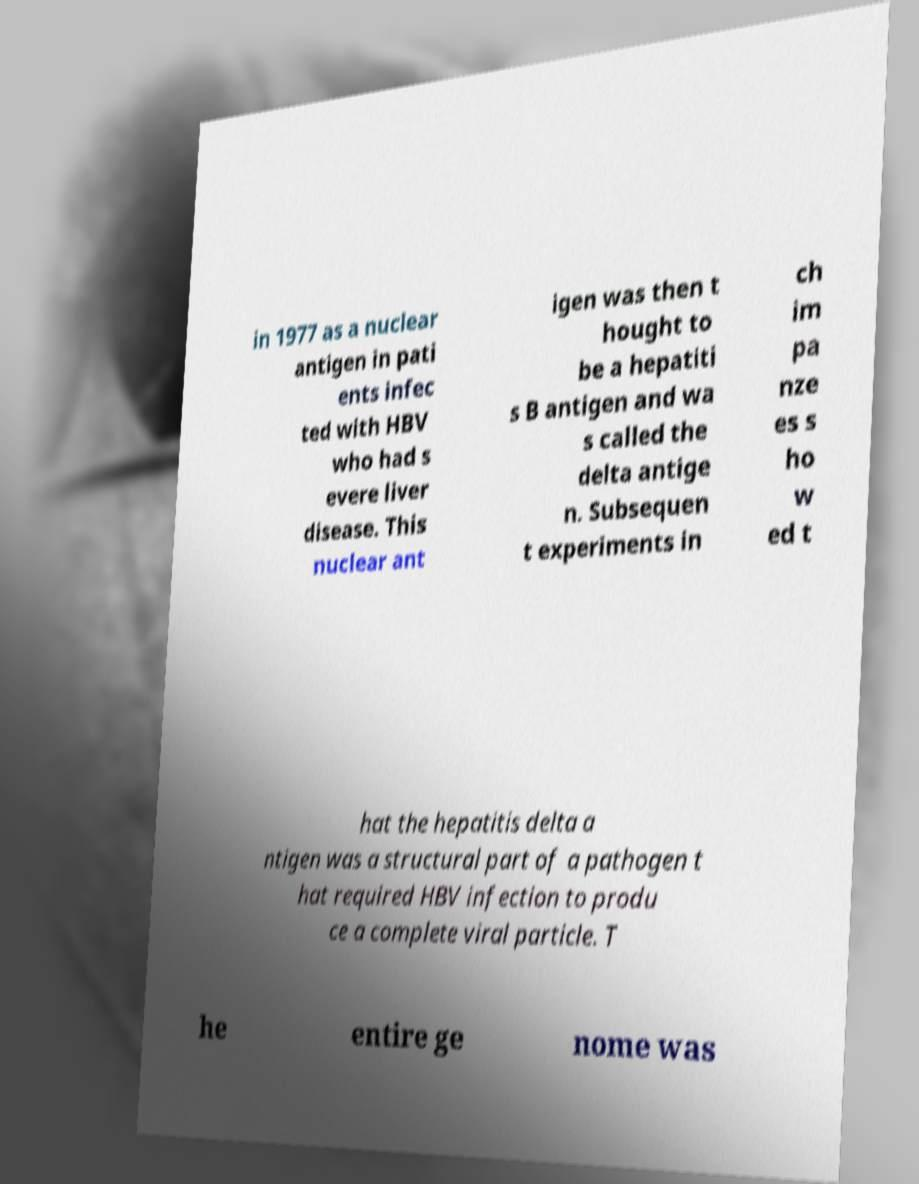For documentation purposes, I need the text within this image transcribed. Could you provide that? in 1977 as a nuclear antigen in pati ents infec ted with HBV who had s evere liver disease. This nuclear ant igen was then t hought to be a hepatiti s B antigen and wa s called the delta antige n. Subsequen t experiments in ch im pa nze es s ho w ed t hat the hepatitis delta a ntigen was a structural part of a pathogen t hat required HBV infection to produ ce a complete viral particle. T he entire ge nome was 